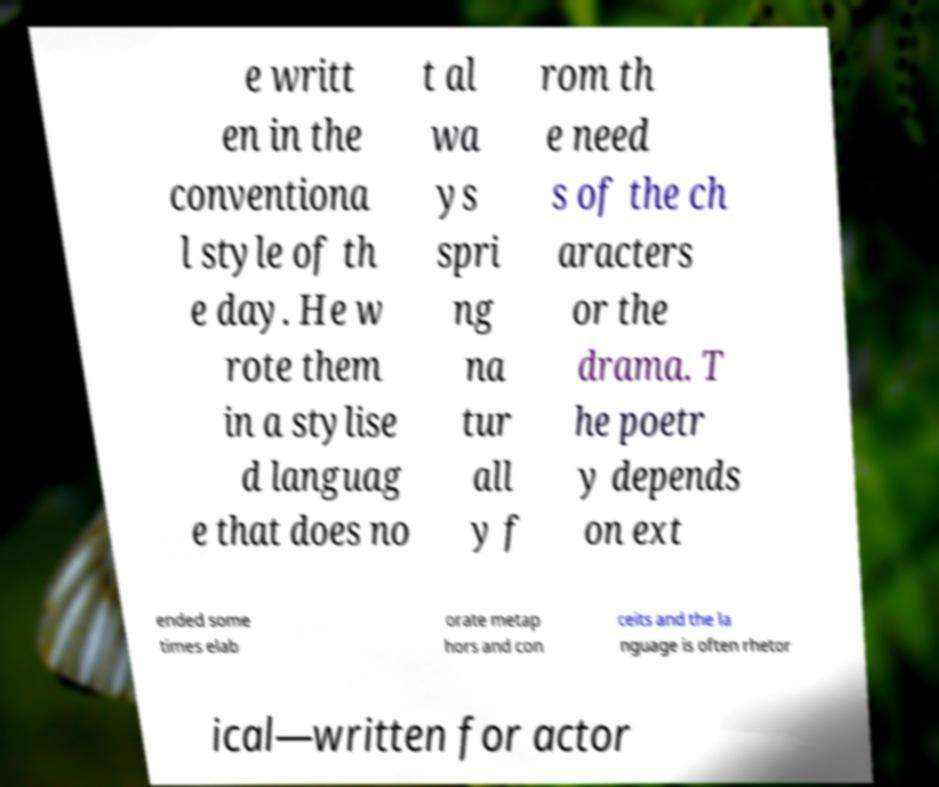I need the written content from this picture converted into text. Can you do that? e writt en in the conventiona l style of th e day. He w rote them in a stylise d languag e that does no t al wa ys spri ng na tur all y f rom th e need s of the ch aracters or the drama. T he poetr y depends on ext ended some times elab orate metap hors and con ceits and the la nguage is often rhetor ical—written for actor 